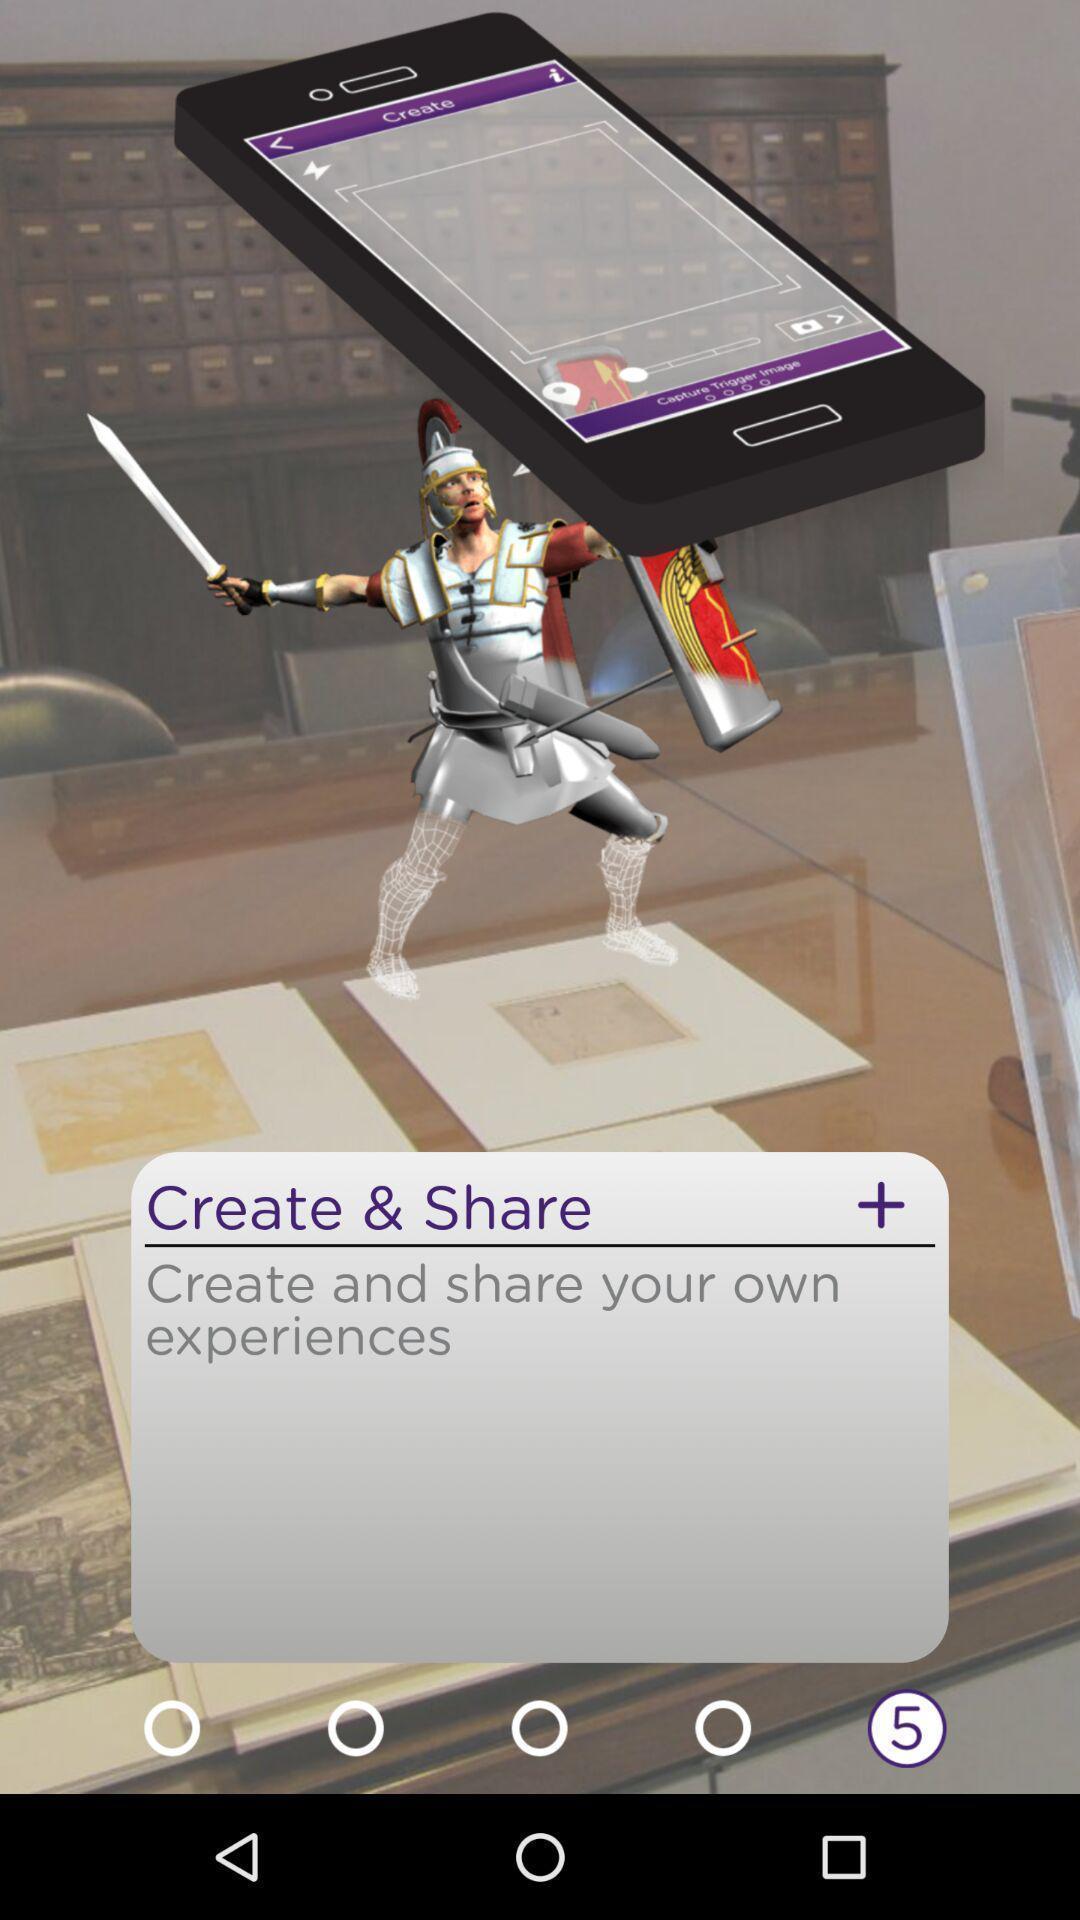What is the overall content of this screenshot? Screen displaying create and share option. 